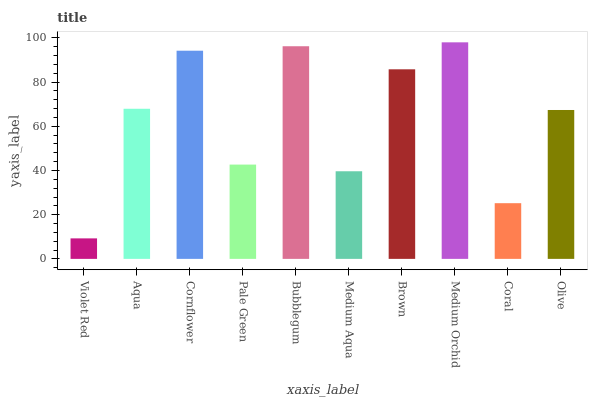Is Violet Red the minimum?
Answer yes or no. Yes. Is Medium Orchid the maximum?
Answer yes or no. Yes. Is Aqua the minimum?
Answer yes or no. No. Is Aqua the maximum?
Answer yes or no. No. Is Aqua greater than Violet Red?
Answer yes or no. Yes. Is Violet Red less than Aqua?
Answer yes or no. Yes. Is Violet Red greater than Aqua?
Answer yes or no. No. Is Aqua less than Violet Red?
Answer yes or no. No. Is Aqua the high median?
Answer yes or no. Yes. Is Olive the low median?
Answer yes or no. Yes. Is Coral the high median?
Answer yes or no. No. Is Pale Green the low median?
Answer yes or no. No. 